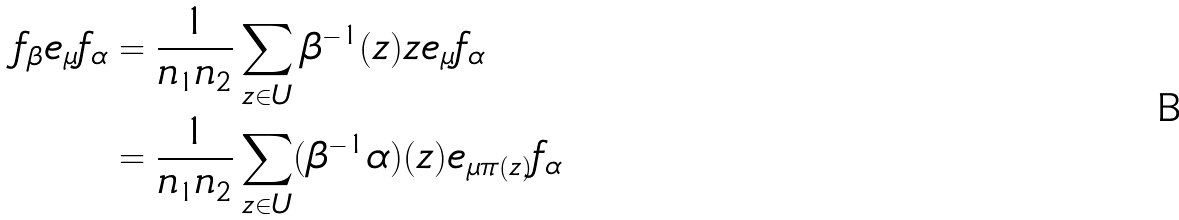Convert formula to latex. <formula><loc_0><loc_0><loc_500><loc_500>f _ { \beta } e _ { \mu } f _ { \alpha } & = \frac { 1 } { n _ { 1 } n _ { 2 } } \sum _ { z \in U } \beta ^ { - 1 } ( z ) z e _ { \mu } f _ { \alpha } \\ & = \frac { 1 } { n _ { 1 } n _ { 2 } } \sum _ { z \in U } ( \beta ^ { - 1 } \alpha ) ( z ) e _ { \mu \pi ( z ) } f _ { \alpha }</formula> 